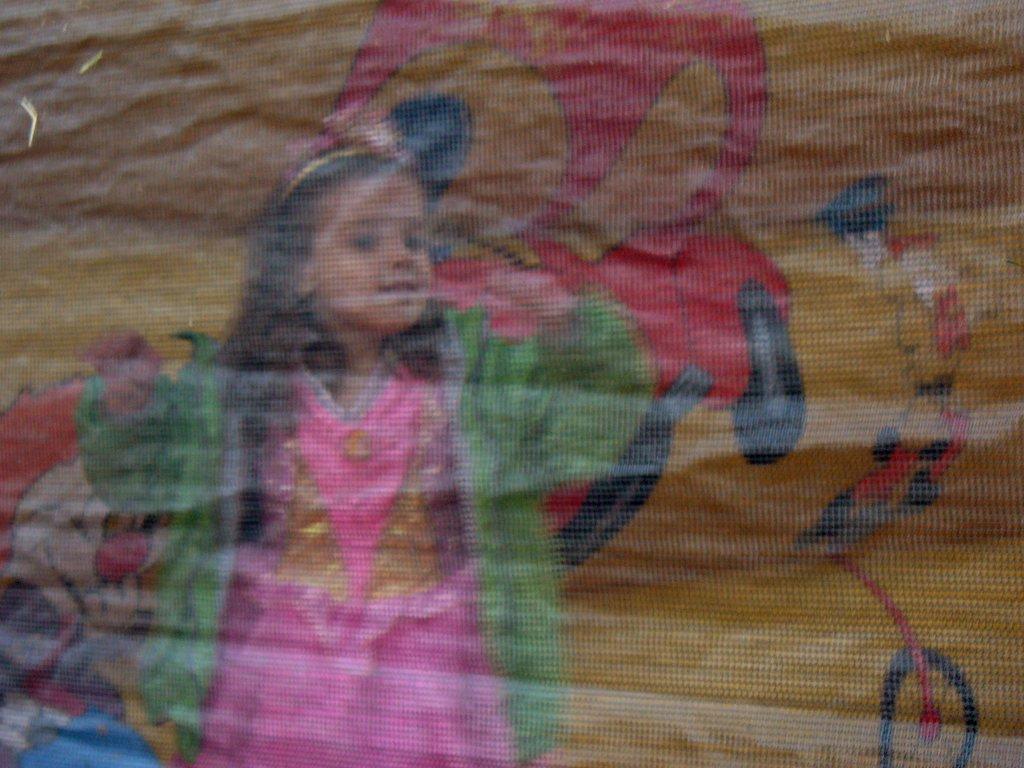Can you describe this image briefly? In this image I see a girl who is wearing pink, gold and green color dress and in the background I see the art. 